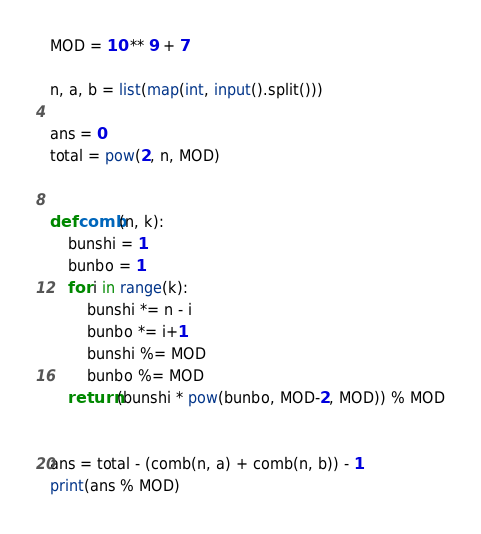<code> <loc_0><loc_0><loc_500><loc_500><_Python_>MOD = 10 ** 9 + 7

n, a, b = list(map(int, input().split()))

ans = 0
total = pow(2, n, MOD)


def comb(n, k):
    bunshi = 1
    bunbo = 1
    for i in range(k):
        bunshi *= n - i
        bunbo *= i+1
        bunshi %= MOD
        bunbo %= MOD
    return (bunshi * pow(bunbo, MOD-2, MOD)) % MOD


ans = total - (comb(n, a) + comb(n, b)) - 1
print(ans % MOD)
</code> 